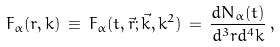<formula> <loc_0><loc_0><loc_500><loc_500>F _ { \alpha } ( r , k ) \, \equiv \, F _ { \alpha } ( t , \vec { r } ; \vec { k } , k ^ { 2 } ) \, = \, \frac { d N _ { \alpha } ( t ) } { d ^ { 3 } r d ^ { 4 } k } \, ,</formula> 